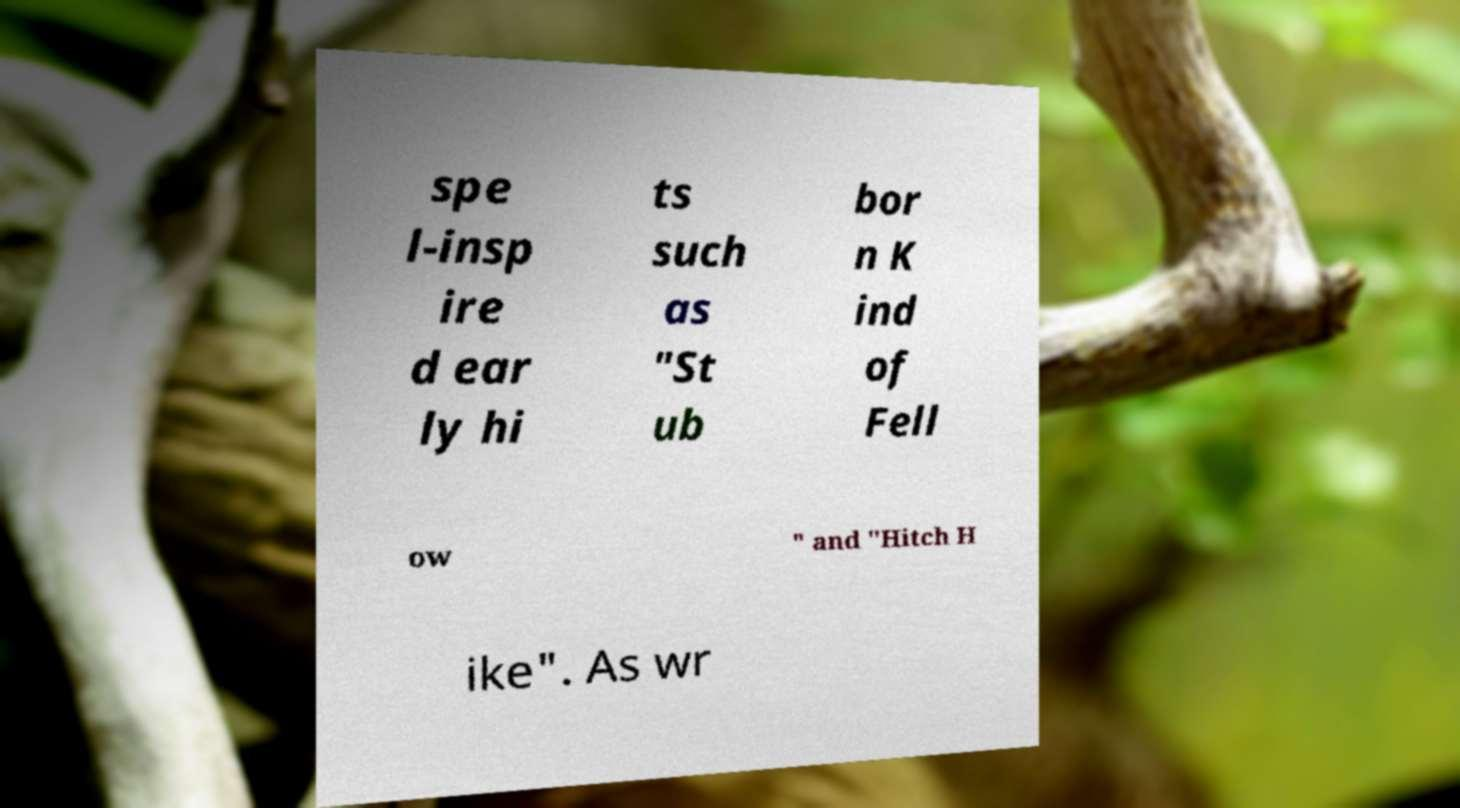Please identify and transcribe the text found in this image. spe l-insp ire d ear ly hi ts such as "St ub bor n K ind of Fell ow " and "Hitch H ike". As wr 